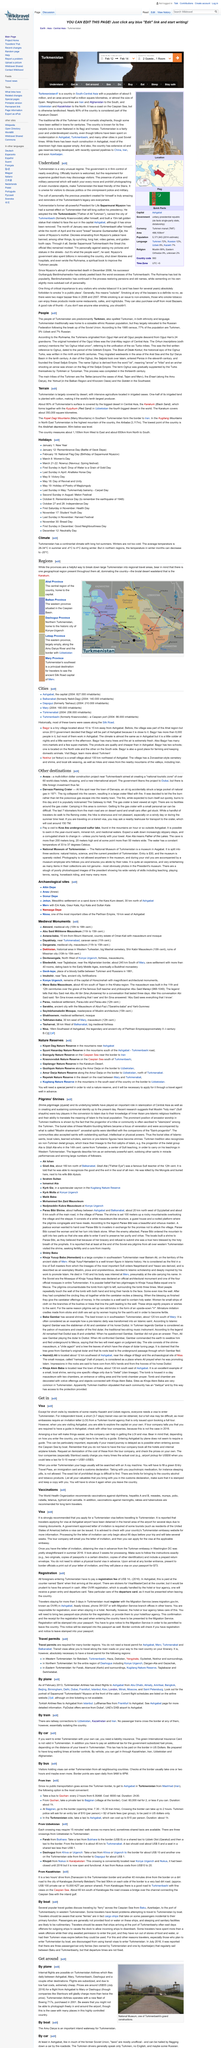Highlight a few significant elements in this photo. It is necessary for a traveler to Turkmenistan to possess a valid Turkmenistan visa in order to legally enter the country. It is highly recommended that travelers apply for their Turkmenistan visa as soon as possible to avoid any potential inconveniences during their trip. It is known that obtaining a visa from the Turkman embassy in Washington DC in summer 2016 took approximately three weeks in advance. The fee for border officials to place a visa in a passport is $73. 